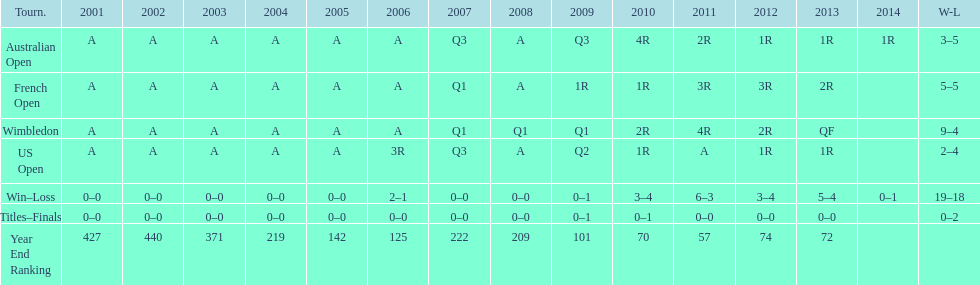What was this players average ranking between 2001 and 2006? 287. 